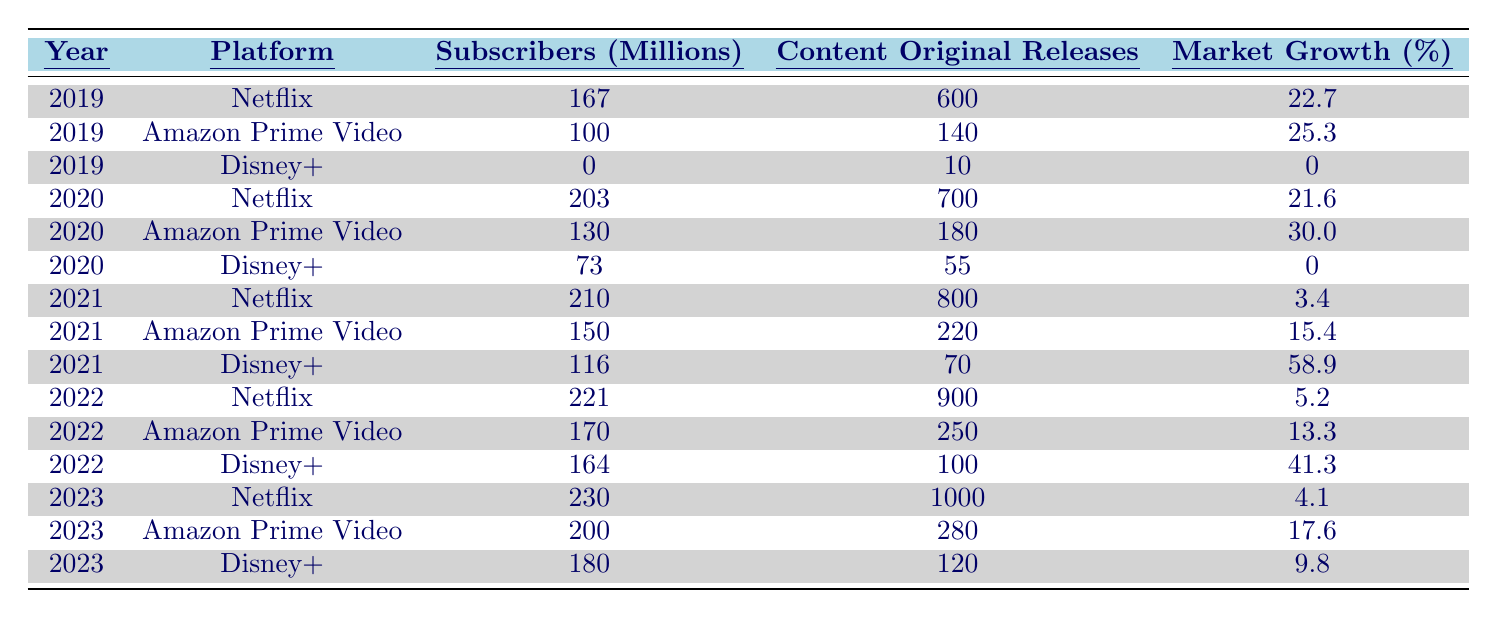What was the total number of subscribers for Netflix in 2022? In the table, the total number of subscribers for Netflix in 2022 is listed as 221 million.
Answer: 221 million What platform had the highest number of original content releases in 2023? Looking at the table for 2023, Netflix has 1000 original releases, which is higher than Amazon Prime Video's 280 and Disney+'s 120.
Answer: Netflix Did Disney+ see any market growth in 2019? The market growth for Disney+ in 2019 is shown as 0%, indicating there was no growth that year.
Answer: No What is the percentage increase in subscribers for Amazon Prime Video from 2020 to 2023? The subscribers for Amazon Prime Video in 2020 were 130 million and rose to 200 million in 2023. To find the increase: (200 - 130) / 130 * 100 = 53.85%.
Answer: 53.85% How many original releases did Disney+ have compared to Netflix in 2021? In 2021, Disney+ had 70 original releases, while Netflix had 800. The difference is 800 - 70 = 730.
Answer: 730 Which platform had the lowest market growth percentage in 2021? Analyzing the market growth percentages for 2021, Netflix had the lowest at 3.4% compared to others: Amazon Prime Video's 15.4% and Disney+'s 58.9%.
Answer: Netflix What was the total number of subscribers for all three platforms in 2022? In 2022, Netflix had 221 million, Amazon Prime Video had 170 million, and Disney+ had 164 million. The total adds up to 221 + 170 + 164 = 555 million.
Answer: 555 million How many subscribers did Disney+ gain from 2020 to 2021? Disney+ had 73 million subscribers in 2020 and increased to 116 million in 2021. The gain is calculated as 116 - 73 = 43 million.
Answer: 43 million What were the original releases for Amazon Prime Video in 2020 and 2022? In 2020, Amazon Prime Video had 180 original releases, and in 2022, it had 250. The difference in original releases is 250 - 180 = 70.
Answer: 70 Which platform had an increase in market growth in 2022 compared to 2021? Comparing the percentages, Amazon Prime Video increased from 15.4% in 2021 to 13.3% in 2022, while Disney+ increased from 58.9% to 41.3%. Thus, only Netflix decreased, while the others declined.
Answer: None What was the average number of original releases across all platforms for the year 2022? The sum of the original releases in 2022 is: Netflix (900) + Amazon Prime Video (250) + Disney+ (100) = 1250. With three platforms, the average is 1250 / 3 = 416.67.
Answer: 416.67 